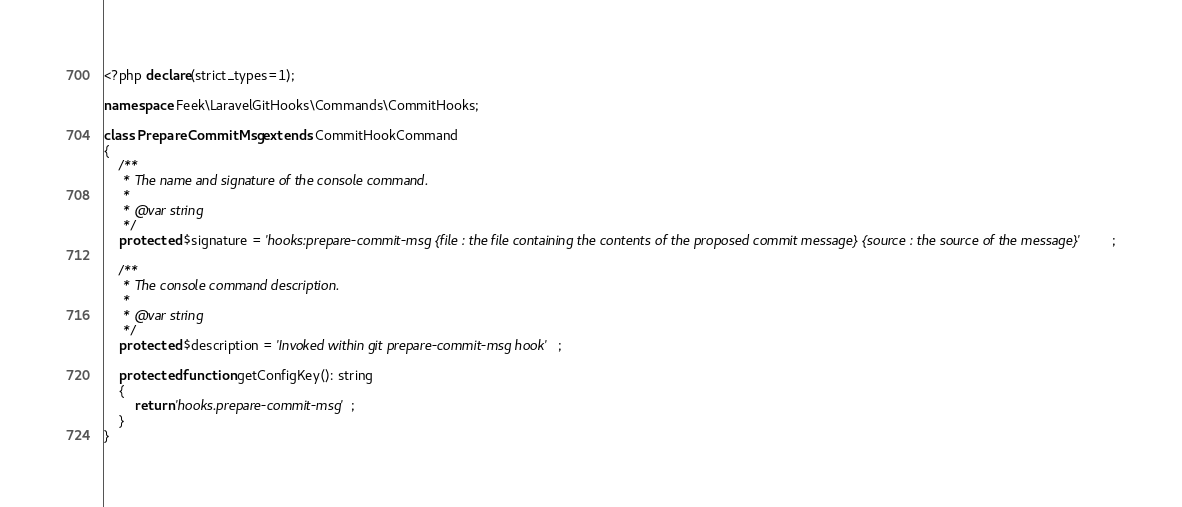Convert code to text. <code><loc_0><loc_0><loc_500><loc_500><_PHP_><?php declare(strict_types=1);

namespace Feek\LaravelGitHooks\Commands\CommitHooks;

class PrepareCommitMsg extends CommitHookCommand
{
    /**
     * The name and signature of the console command.
     *
     * @var string
     */
    protected $signature = 'hooks:prepare-commit-msg {file : the file containing the contents of the proposed commit message} {source : the source of the message}';

    /**
     * The console command description.
     *
     * @var string
     */
    protected $description = 'Invoked within git prepare-commit-msg hook';

    protected function getConfigKey(): string
    {
        return 'hooks.prepare-commit-msg';
    }
}
</code> 